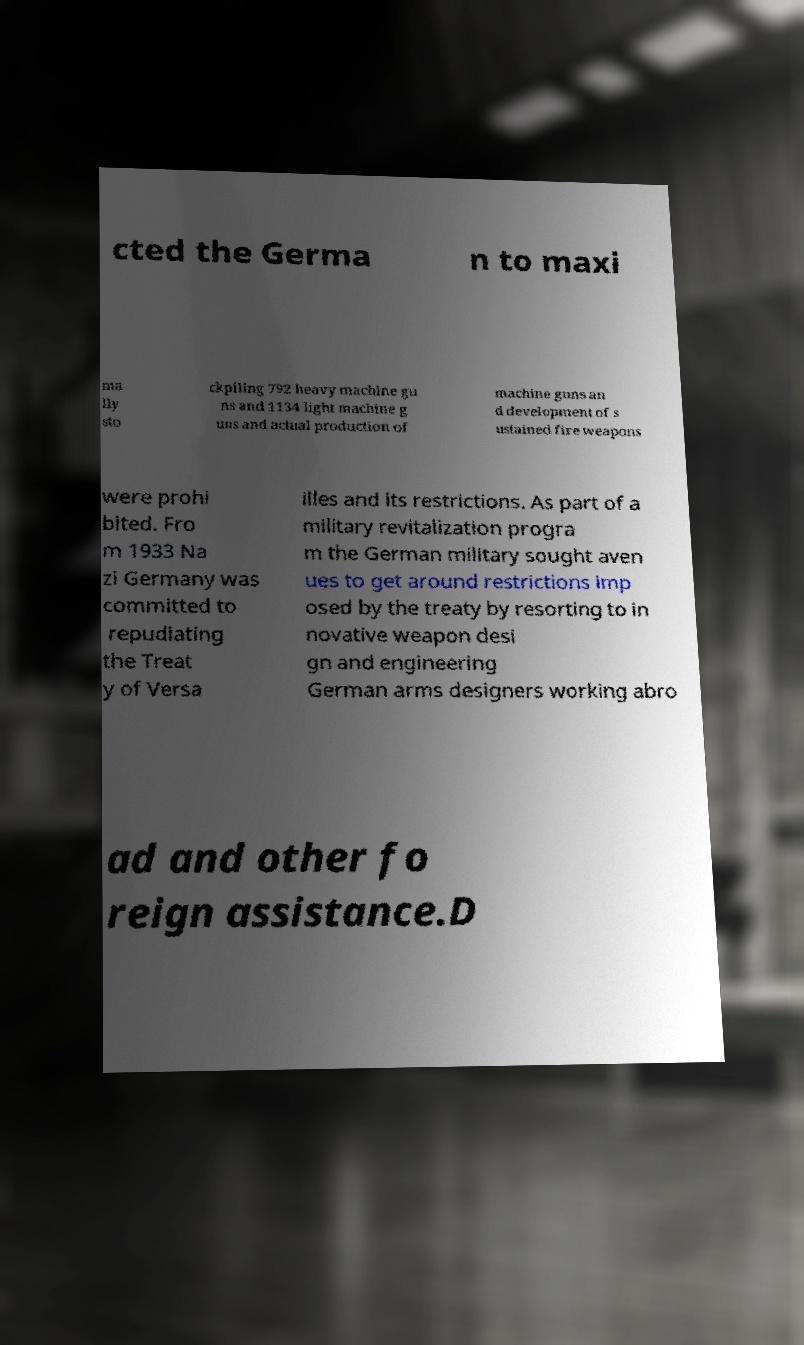There's text embedded in this image that I need extracted. Can you transcribe it verbatim? cted the Germa n to maxi ma lly sto ckpiling 792 heavy machine gu ns and 1134 light machine g uns and actual production of machine guns an d development of s ustained fire weapons were prohi bited. Fro m 1933 Na zi Germany was committed to repudiating the Treat y of Versa illes and its restrictions. As part of a military revitalization progra m the German military sought aven ues to get around restrictions imp osed by the treaty by resorting to in novative weapon desi gn and engineering German arms designers working abro ad and other fo reign assistance.D 